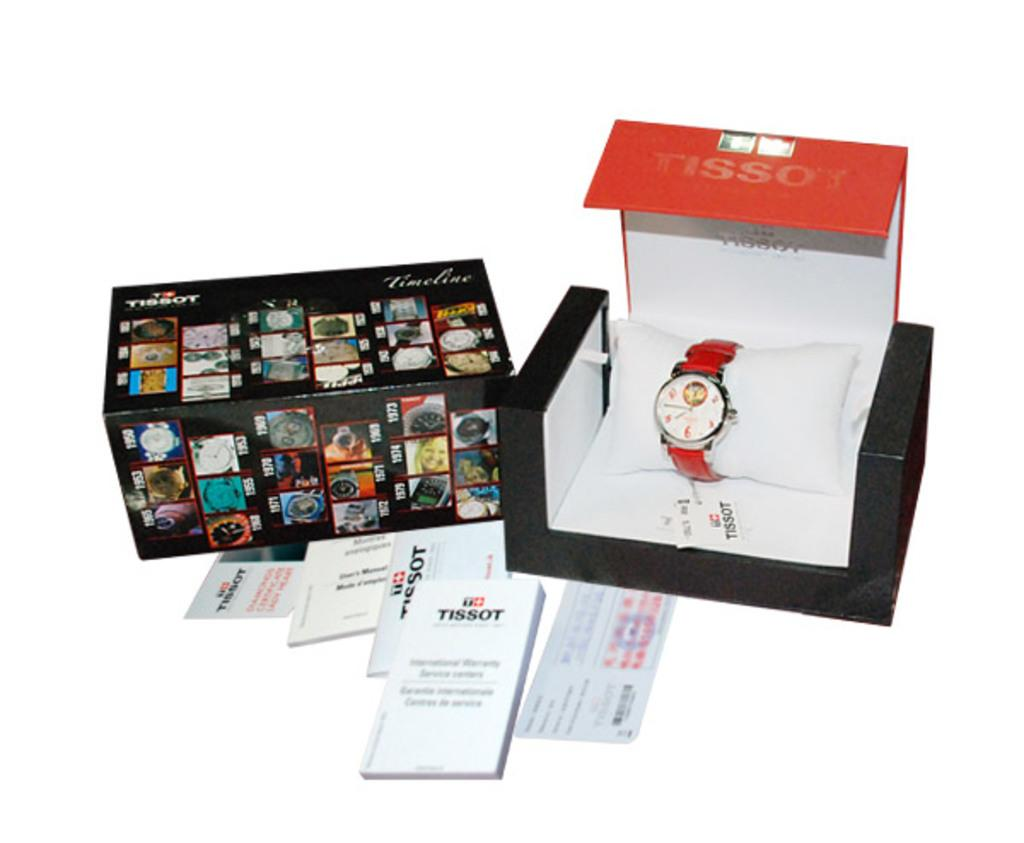<image>
Relay a brief, clear account of the picture shown. A Tissot watch is in a box next to various documentation. 